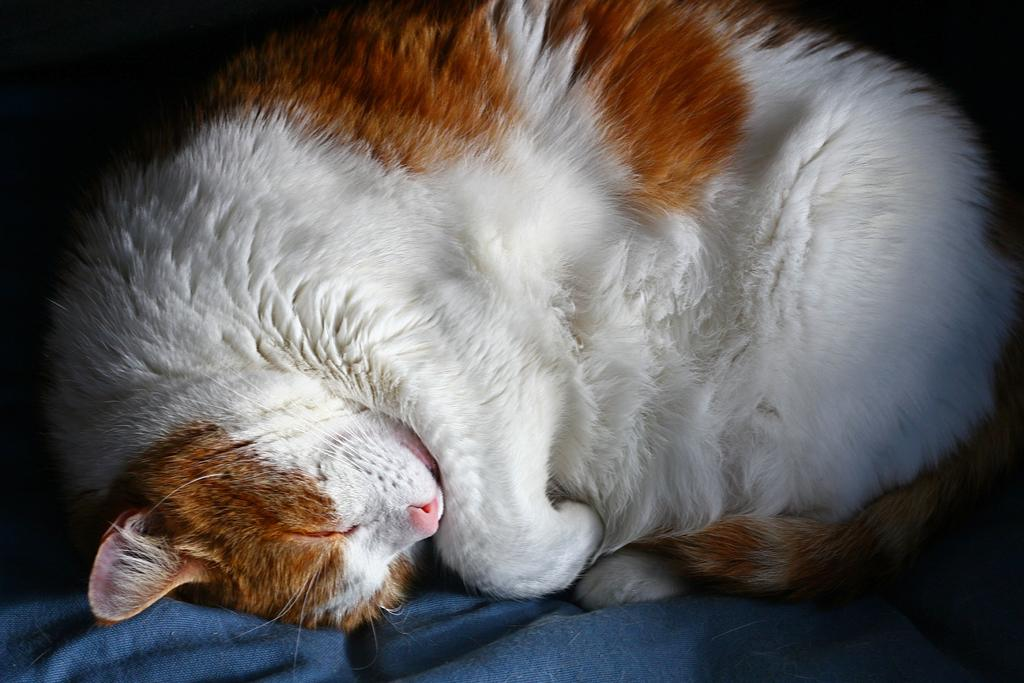What type of animal is in the image? There is a cat in the image. What colors can be seen on the cat? The cat is white and brown in color. What is the cat doing in the image? The cat is sleeping. What type of lettuce is the snail eating in the image? There is no snail or lettuce present in the image; it only features a cat. 